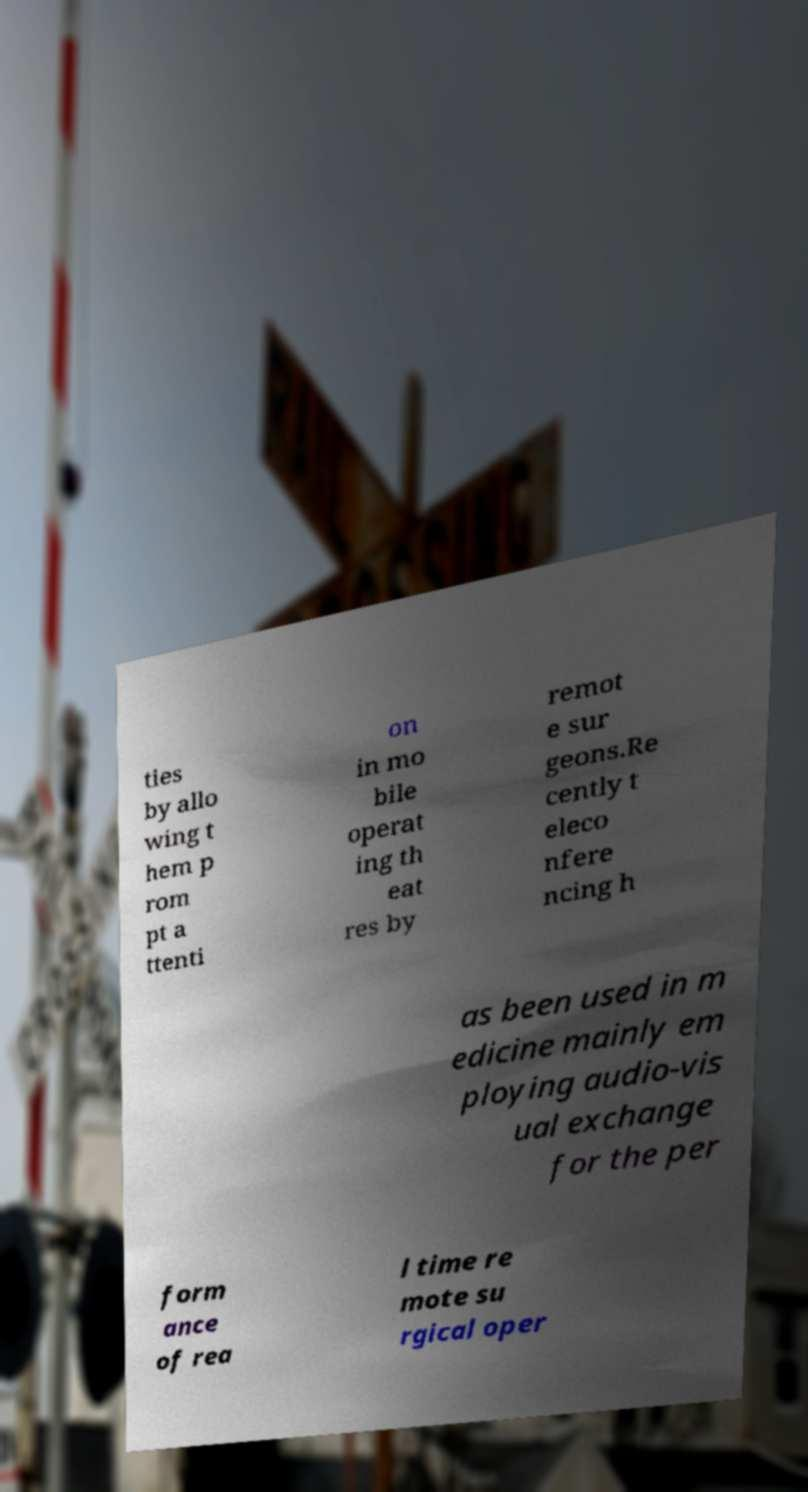Could you extract and type out the text from this image? ties by allo wing t hem p rom pt a ttenti on in mo bile operat ing th eat res by remot e sur geons.Re cently t eleco nfere ncing h as been used in m edicine mainly em ploying audio-vis ual exchange for the per form ance of rea l time re mote su rgical oper 